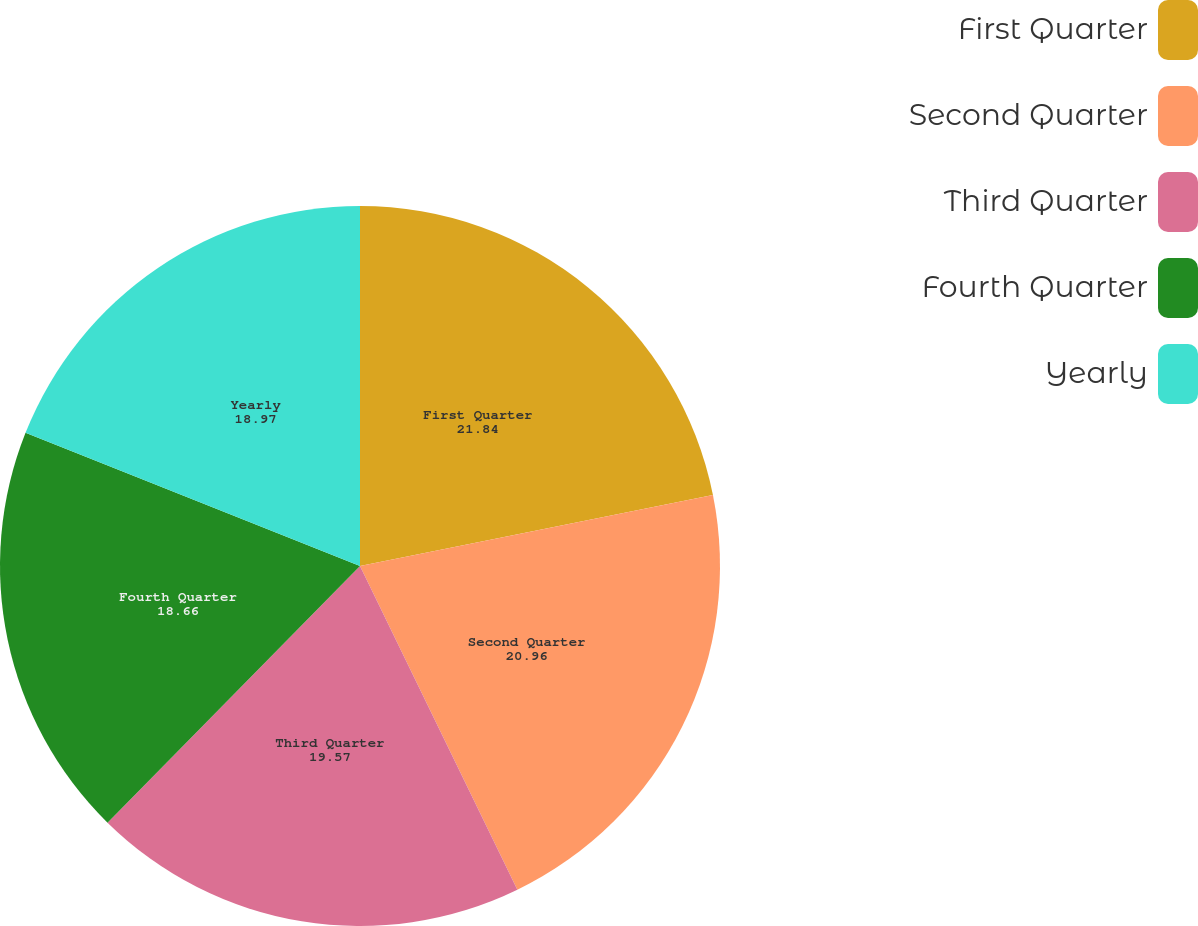Convert chart to OTSL. <chart><loc_0><loc_0><loc_500><loc_500><pie_chart><fcel>First Quarter<fcel>Second Quarter<fcel>Third Quarter<fcel>Fourth Quarter<fcel>Yearly<nl><fcel>21.84%<fcel>20.96%<fcel>19.57%<fcel>18.66%<fcel>18.97%<nl></chart> 